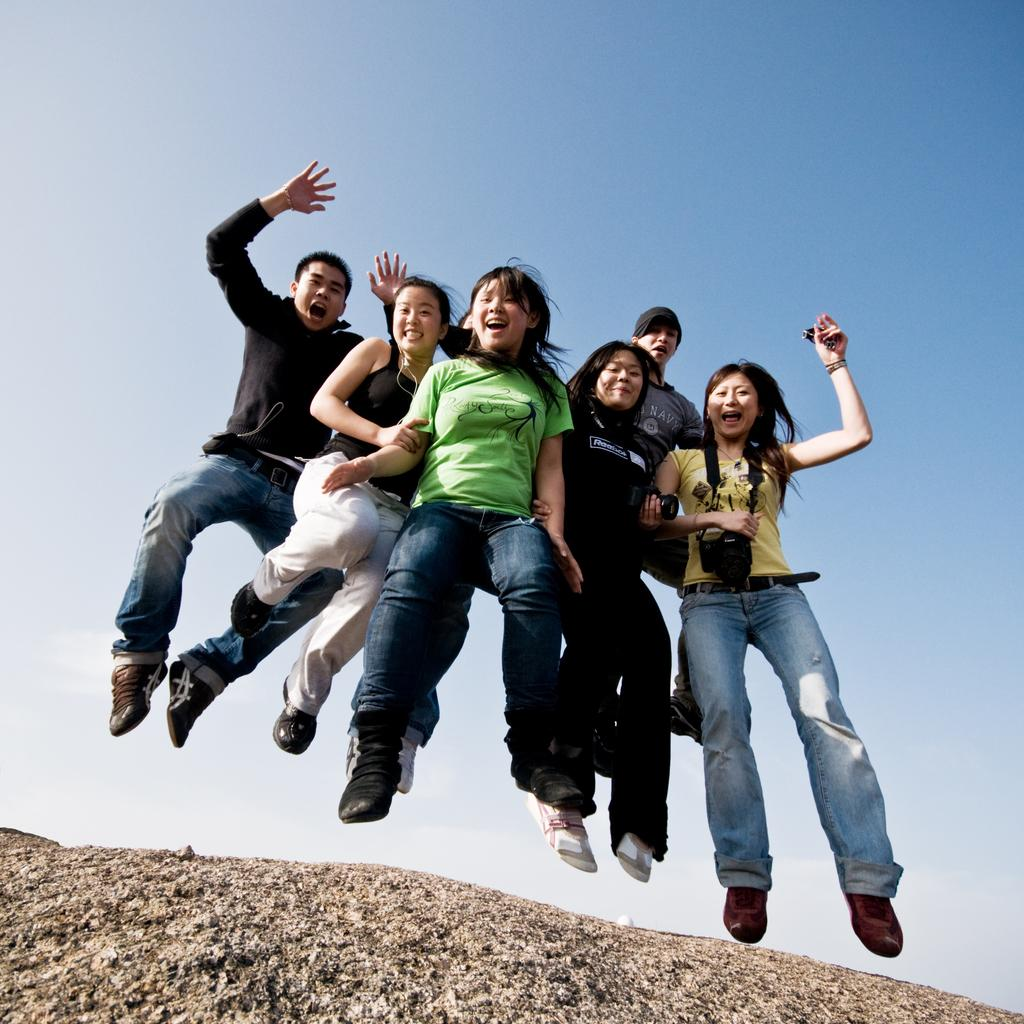What are the persons in the image doing? The persons in the image are jumping. What is at the bottom of the image? There is a ground at the bottom of the image. What can be seen in the background of the image? The sky is visible in the background of the image. What type of pump is visible in the image? There is no pump present in the image. Is there a tent in the image? No, there is no tent in the image. 